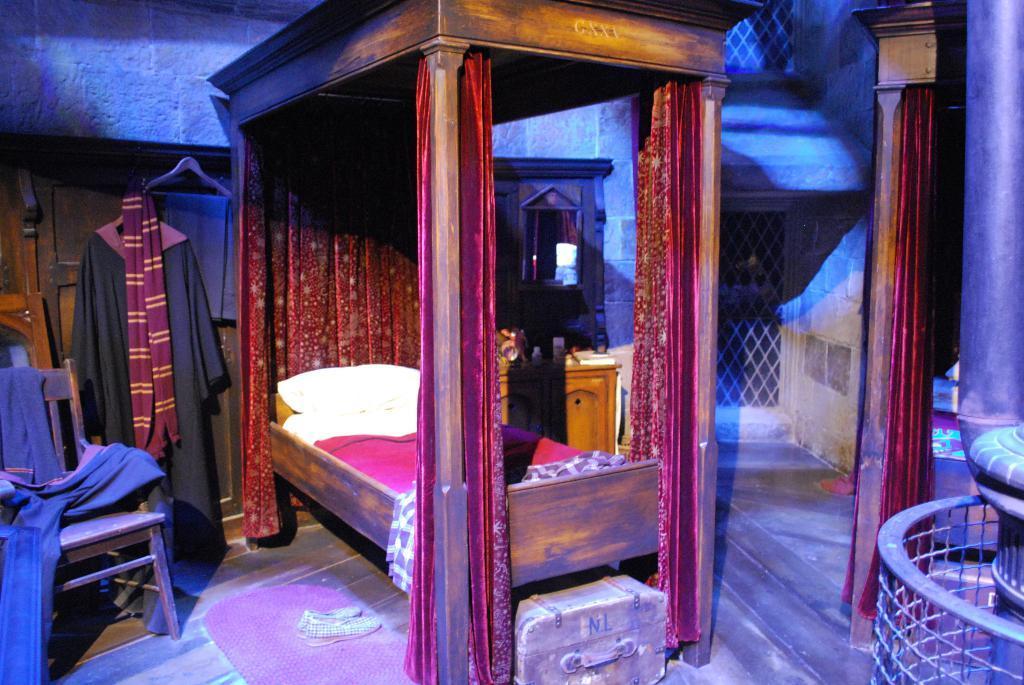Could you give a brief overview of what you see in this image? In the image we can see there is a bed and there is a suitcase under the bed and there are shoes and door mat on the floor and there is a chair and a jacket and a scarf. 